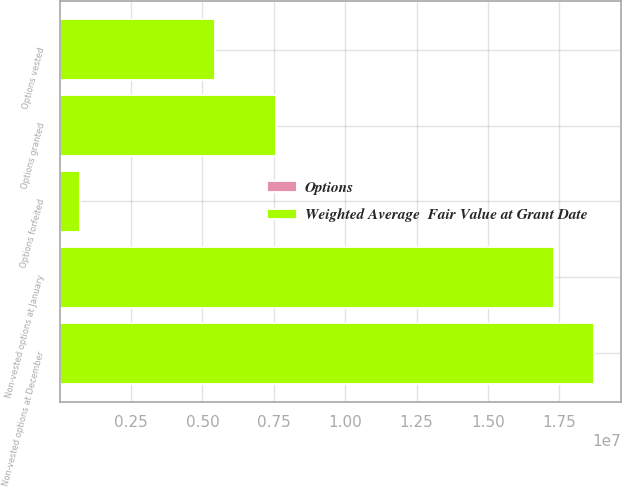<chart> <loc_0><loc_0><loc_500><loc_500><stacked_bar_chart><ecel><fcel>Non-vested options at January<fcel>Options granted<fcel>Options vested<fcel>Options forfeited<fcel>Non-vested options at December<nl><fcel>Weighted Average  Fair Value at Grant Date<fcel>1.7323e+07<fcel>7.56045e+06<fcel>5.43064e+06<fcel>727280<fcel>1.87256e+07<nl><fcel>Options<fcel>8.24<fcel>7.39<fcel>7.93<fcel>8.28<fcel>7.99<nl></chart> 